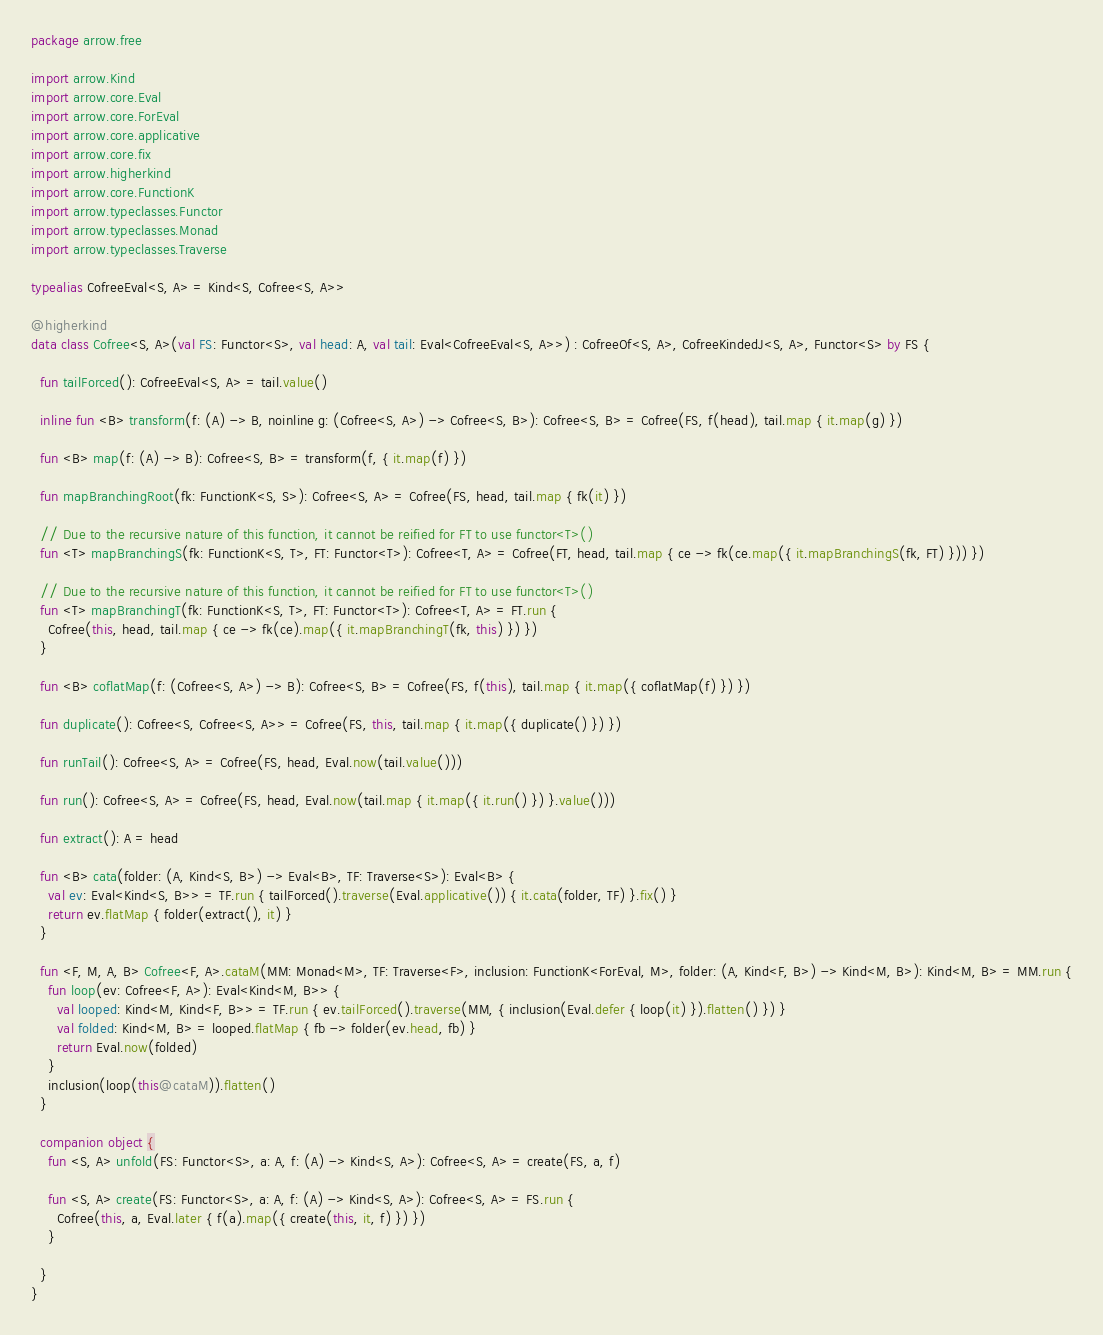Convert code to text. <code><loc_0><loc_0><loc_500><loc_500><_Kotlin_>package arrow.free

import arrow.Kind
import arrow.core.Eval
import arrow.core.ForEval
import arrow.core.applicative
import arrow.core.fix
import arrow.higherkind
import arrow.core.FunctionK
import arrow.typeclasses.Functor
import arrow.typeclasses.Monad
import arrow.typeclasses.Traverse

typealias CofreeEval<S, A> = Kind<S, Cofree<S, A>>

@higherkind
data class Cofree<S, A>(val FS: Functor<S>, val head: A, val tail: Eval<CofreeEval<S, A>>) : CofreeOf<S, A>, CofreeKindedJ<S, A>, Functor<S> by FS {

  fun tailForced(): CofreeEval<S, A> = tail.value()

  inline fun <B> transform(f: (A) -> B, noinline g: (Cofree<S, A>) -> Cofree<S, B>): Cofree<S, B> = Cofree(FS, f(head), tail.map { it.map(g) })

  fun <B> map(f: (A) -> B): Cofree<S, B> = transform(f, { it.map(f) })

  fun mapBranchingRoot(fk: FunctionK<S, S>): Cofree<S, A> = Cofree(FS, head, tail.map { fk(it) })

  // Due to the recursive nature of this function, it cannot be reified for FT to use functor<T>()
  fun <T> mapBranchingS(fk: FunctionK<S, T>, FT: Functor<T>): Cofree<T, A> = Cofree(FT, head, tail.map { ce -> fk(ce.map({ it.mapBranchingS(fk, FT) })) })

  // Due to the recursive nature of this function, it cannot be reified for FT to use functor<T>()
  fun <T> mapBranchingT(fk: FunctionK<S, T>, FT: Functor<T>): Cofree<T, A> = FT.run {
    Cofree(this, head, tail.map { ce -> fk(ce).map({ it.mapBranchingT(fk, this) }) })
  }

  fun <B> coflatMap(f: (Cofree<S, A>) -> B): Cofree<S, B> = Cofree(FS, f(this), tail.map { it.map({ coflatMap(f) }) })

  fun duplicate(): Cofree<S, Cofree<S, A>> = Cofree(FS, this, tail.map { it.map({ duplicate() }) })

  fun runTail(): Cofree<S, A> = Cofree(FS, head, Eval.now(tail.value()))

  fun run(): Cofree<S, A> = Cofree(FS, head, Eval.now(tail.map { it.map({ it.run() }) }.value()))

  fun extract(): A = head

  fun <B> cata(folder: (A, Kind<S, B>) -> Eval<B>, TF: Traverse<S>): Eval<B> {
    val ev: Eval<Kind<S, B>> = TF.run { tailForced().traverse(Eval.applicative()) { it.cata(folder, TF) }.fix() }
    return ev.flatMap { folder(extract(), it) }
  }

  fun <F, M, A, B> Cofree<F, A>.cataM(MM: Monad<M>, TF: Traverse<F>, inclusion: FunctionK<ForEval, M>, folder: (A, Kind<F, B>) -> Kind<M, B>): Kind<M, B> = MM.run {
    fun loop(ev: Cofree<F, A>): Eval<Kind<M, B>> {
      val looped: Kind<M, Kind<F, B>> = TF.run { ev.tailForced().traverse(MM, { inclusion(Eval.defer { loop(it) }).flatten() }) }
      val folded: Kind<M, B> = looped.flatMap { fb -> folder(ev.head, fb) }
      return Eval.now(folded)
    }
    inclusion(loop(this@cataM)).flatten()
  }

  companion object {
    fun <S, A> unfold(FS: Functor<S>, a: A, f: (A) -> Kind<S, A>): Cofree<S, A> = create(FS, a, f)

    fun <S, A> create(FS: Functor<S>, a: A, f: (A) -> Kind<S, A>): Cofree<S, A> = FS.run {
      Cofree(this, a, Eval.later { f(a).map({ create(this, it, f) }) })
    }

  }
}
</code> 